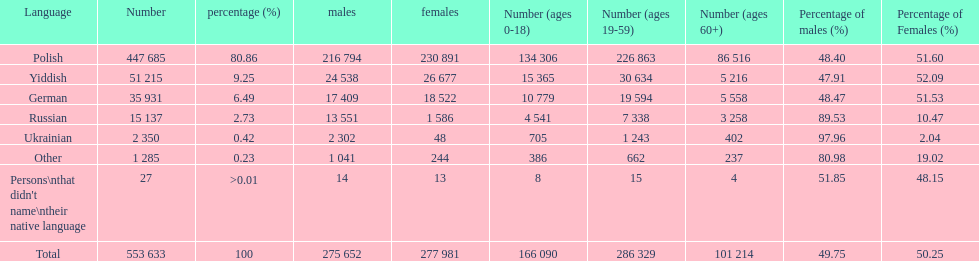Parse the full table. {'header': ['Language', 'Number', 'percentage (%)', 'males', 'females', 'Number (ages 0-18)', 'Number (ages 19-59)', 'Number (ages 60+)', 'Percentage of males (%)', 'Percentage of Females (%)'], 'rows': [['Polish', '447 685', '80.86', '216 794', '230 891', '134 306', '226 863', '86 516', '48.40', '51.60'], ['Yiddish', '51 215', '9.25', '24 538', '26 677', '15 365', '30 634', '5 216', '47.91', '52.09'], ['German', '35 931', '6.49', '17 409', '18 522', '10 779', '19 594', '5 558', '48.47', '51.53'], ['Russian', '15 137', '2.73', '13 551', '1 586', '4 541', '7 338', '3 258', '89.53', '10.47'], ['Ukrainian', '2 350', '0.42', '2 302', '48', '705', '1 243', '402', '97.96', '2.04'], ['Other', '1 285', '0.23', '1 041', '244', '386', '662', '237', '80.98', '19.02'], ["Persons\\nthat didn't name\\ntheir native language", '27', '>0.01', '14', '13', '8', '15', '4', '51.85', '48.15'], ['Total', '553 633', '100', '275 652', '277 981', '166 090', '286 329', '101 214', '49.75', '50.25']]} What are the percentages of people? 80.86, 9.25, 6.49, 2.73, 0.42, 0.23, >0.01. Which language is .42%? Ukrainian. 